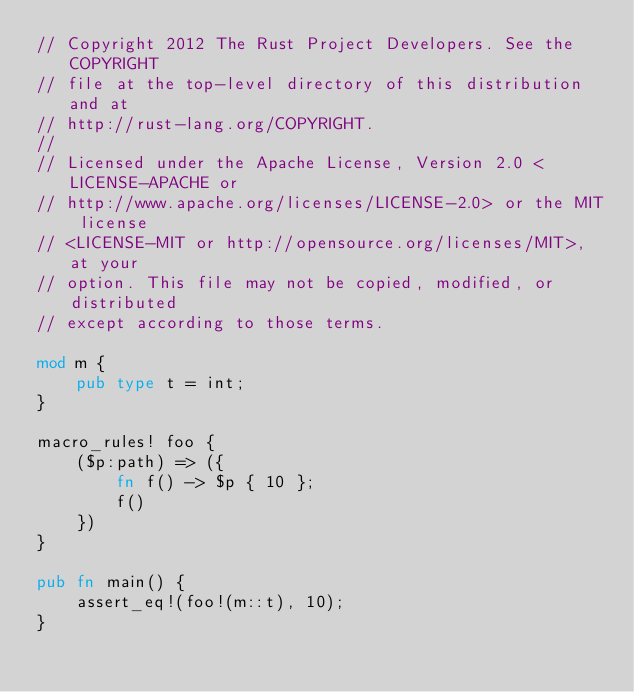<code> <loc_0><loc_0><loc_500><loc_500><_Rust_>// Copyright 2012 The Rust Project Developers. See the COPYRIGHT
// file at the top-level directory of this distribution and at
// http://rust-lang.org/COPYRIGHT.
//
// Licensed under the Apache License, Version 2.0 <LICENSE-APACHE or
// http://www.apache.org/licenses/LICENSE-2.0> or the MIT license
// <LICENSE-MIT or http://opensource.org/licenses/MIT>, at your
// option. This file may not be copied, modified, or distributed
// except according to those terms.

mod m {
    pub type t = int;
}

macro_rules! foo {
    ($p:path) => ({
        fn f() -> $p { 10 };
        f()
    })
}

pub fn main() {
    assert_eq!(foo!(m::t), 10);
}
</code> 